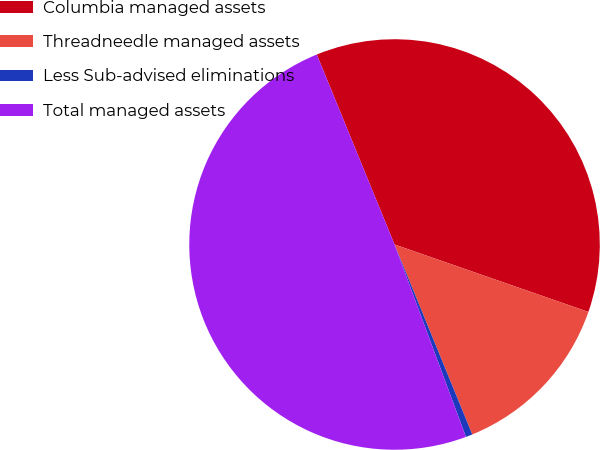Convert chart. <chart><loc_0><loc_0><loc_500><loc_500><pie_chart><fcel>Columbia managed assets<fcel>Threadneedle managed assets<fcel>Less Sub-advised eliminations<fcel>Total managed assets<nl><fcel>36.51%<fcel>13.49%<fcel>0.53%<fcel>49.47%<nl></chart> 